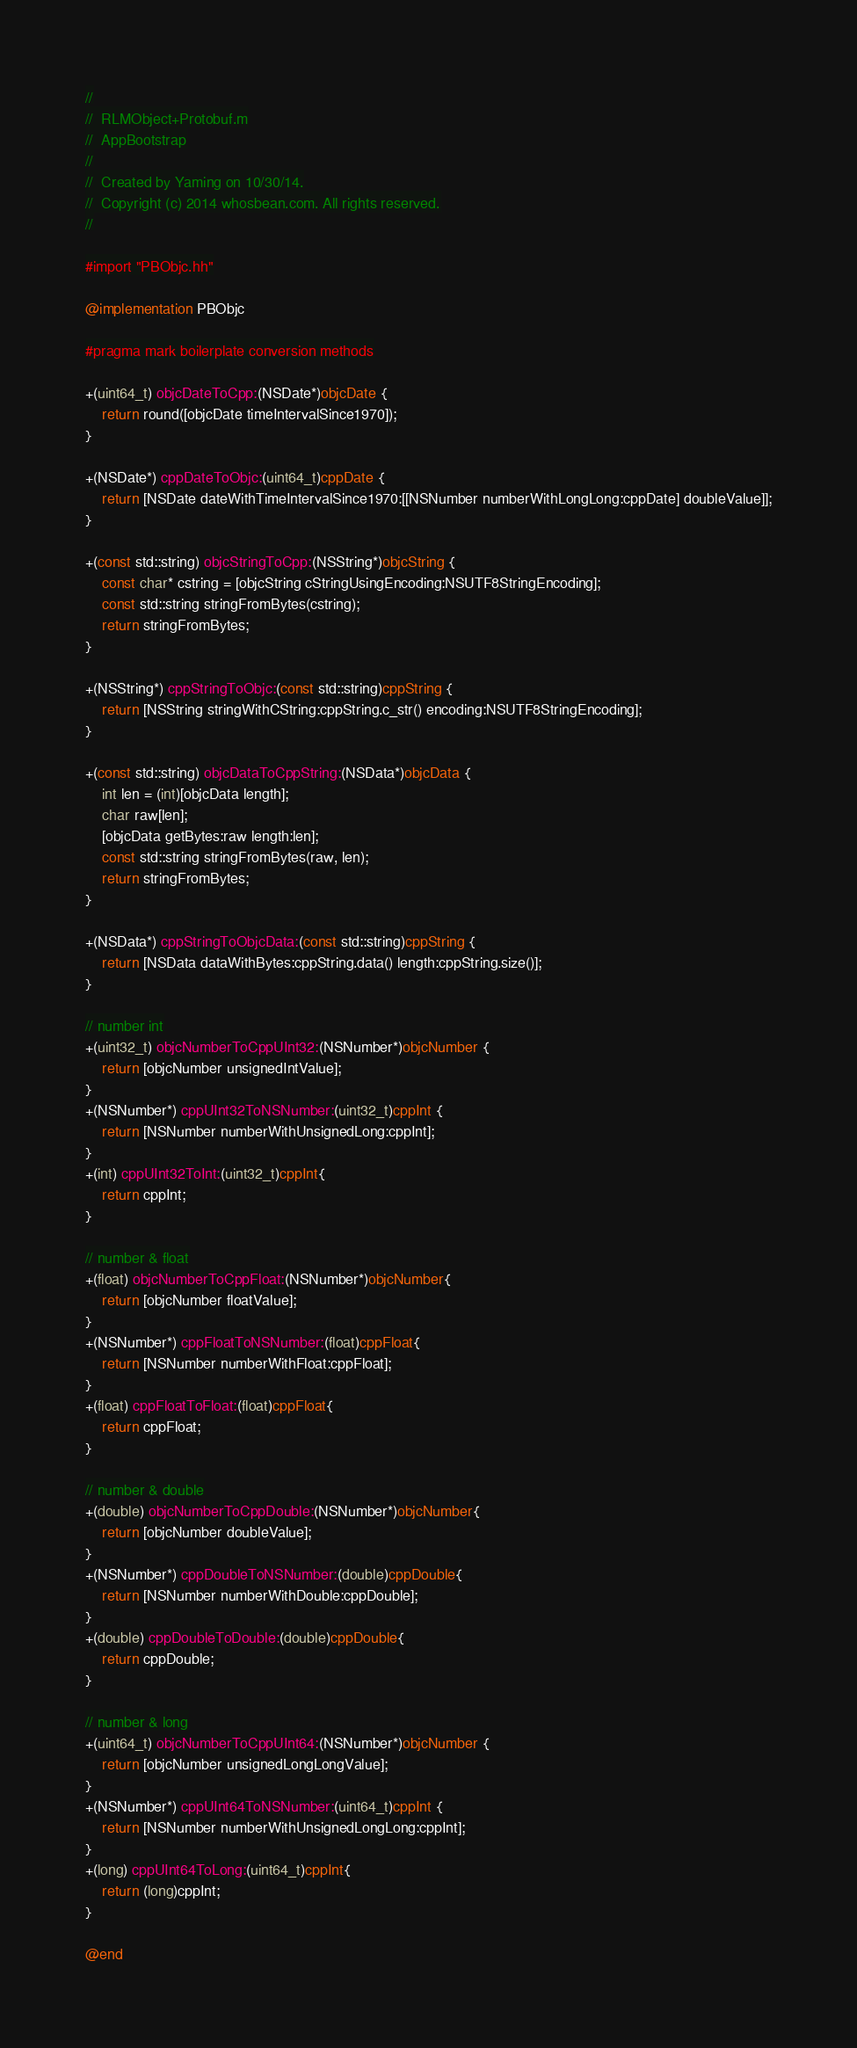<code> <loc_0><loc_0><loc_500><loc_500><_ObjectiveC_>//
//  RLMObject+Protobuf.m
//  AppBootstrap
//
//  Created by Yaming on 10/30/14.
//  Copyright (c) 2014 whosbean.com. All rights reserved.
//

#import "PBObjc.hh"

@implementation PBObjc

#pragma mark boilerplate conversion methods

+(uint64_t) objcDateToCpp:(NSDate*)objcDate {
    return round([objcDate timeIntervalSince1970]);
}

+(NSDate*) cppDateToObjc:(uint64_t)cppDate {
    return [NSDate dateWithTimeIntervalSince1970:[[NSNumber numberWithLongLong:cppDate] doubleValue]];
}

+(const std::string) objcStringToCpp:(NSString*)objcString {
    const char* cstring = [objcString cStringUsingEncoding:NSUTF8StringEncoding];
    const std::string stringFromBytes(cstring);
    return stringFromBytes;
}

+(NSString*) cppStringToObjc:(const std::string)cppString {
    return [NSString stringWithCString:cppString.c_str() encoding:NSUTF8StringEncoding];
}

+(const std::string) objcDataToCppString:(NSData*)objcData {
    int len = (int)[objcData length];
    char raw[len];
    [objcData getBytes:raw length:len];
    const std::string stringFromBytes(raw, len);
    return stringFromBytes;
}

+(NSData*) cppStringToObjcData:(const std::string)cppString {
    return [NSData dataWithBytes:cppString.data() length:cppString.size()];
}

// number int
+(uint32_t) objcNumberToCppUInt32:(NSNumber*)objcNumber {
    return [objcNumber unsignedIntValue];
}
+(NSNumber*) cppUInt32ToNSNumber:(uint32_t)cppInt {
    return [NSNumber numberWithUnsignedLong:cppInt];
}
+(int) cppUInt32ToInt:(uint32_t)cppInt{
    return cppInt;
}

// number & float
+(float) objcNumberToCppFloat:(NSNumber*)objcNumber{
    return [objcNumber floatValue];
}
+(NSNumber*) cppFloatToNSNumber:(float)cppFloat{
    return [NSNumber numberWithFloat:cppFloat];
}
+(float) cppFloatToFloat:(float)cppFloat{
    return cppFloat;
}

// number & double
+(double) objcNumberToCppDouble:(NSNumber*)objcNumber{
    return [objcNumber doubleValue];
}
+(NSNumber*) cppDoubleToNSNumber:(double)cppDouble{
    return [NSNumber numberWithDouble:cppDouble];
}
+(double) cppDoubleToDouble:(double)cppDouble{
    return cppDouble;
}

// number & long
+(uint64_t) objcNumberToCppUInt64:(NSNumber*)objcNumber {
    return [objcNumber unsignedLongLongValue];
}
+(NSNumber*) cppUInt64ToNSNumber:(uint64_t)cppInt {
    return [NSNumber numberWithUnsignedLongLong:cppInt];
}
+(long) cppUInt64ToLong:(uint64_t)cppInt{
    return (long)cppInt;
}

@end
</code> 